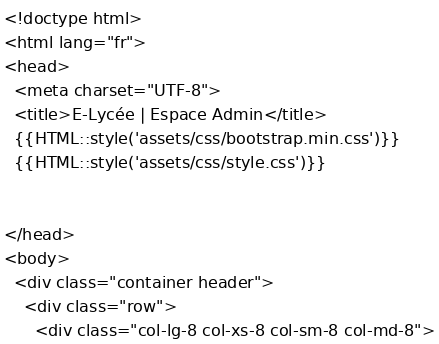Convert code to text. <code><loc_0><loc_0><loc_500><loc_500><_PHP_><!doctype html>
<html lang="fr">
<head>
  <meta charset="UTF-8">
  <title>E-Lycée | Espace Admin</title>
  {{HTML::style('assets/css/bootstrap.min.css')}}
  {{HTML::style('assets/css/style.css')}}


</head>
<body>
  <div class="container header">
    <div class="row">
      <div class="col-lg-8 col-xs-8 col-sm-8 col-md-8"></code> 